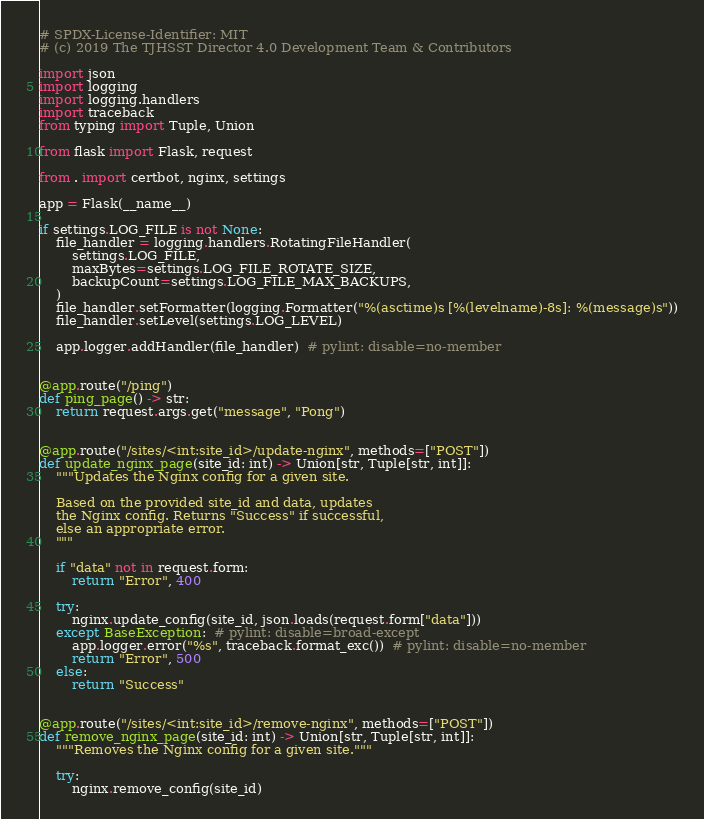Convert code to text. <code><loc_0><loc_0><loc_500><loc_500><_Python_># SPDX-License-Identifier: MIT
# (c) 2019 The TJHSST Director 4.0 Development Team & Contributors

import json
import logging
import logging.handlers
import traceback
from typing import Tuple, Union

from flask import Flask, request

from . import certbot, nginx, settings

app = Flask(__name__)

if settings.LOG_FILE is not None:
    file_handler = logging.handlers.RotatingFileHandler(
        settings.LOG_FILE,
        maxBytes=settings.LOG_FILE_ROTATE_SIZE,
        backupCount=settings.LOG_FILE_MAX_BACKUPS,
    )
    file_handler.setFormatter(logging.Formatter("%(asctime)s [%(levelname)-8s]: %(message)s"))
    file_handler.setLevel(settings.LOG_LEVEL)

    app.logger.addHandler(file_handler)  # pylint: disable=no-member


@app.route("/ping")
def ping_page() -> str:
    return request.args.get("message", "Pong")


@app.route("/sites/<int:site_id>/update-nginx", methods=["POST"])
def update_nginx_page(site_id: int) -> Union[str, Tuple[str, int]]:
    """Updates the Nginx config for a given site.

    Based on the provided site_id and data, updates
    the Nginx config. Returns "Success" if successful,
    else an appropriate error.
    """

    if "data" not in request.form:
        return "Error", 400

    try:
        nginx.update_config(site_id, json.loads(request.form["data"]))
    except BaseException:  # pylint: disable=broad-except
        app.logger.error("%s", traceback.format_exc())  # pylint: disable=no-member
        return "Error", 500
    else:
        return "Success"


@app.route("/sites/<int:site_id>/remove-nginx", methods=["POST"])
def remove_nginx_page(site_id: int) -> Union[str, Tuple[str, int]]:
    """Removes the Nginx config for a given site."""

    try:
        nginx.remove_config(site_id)</code> 